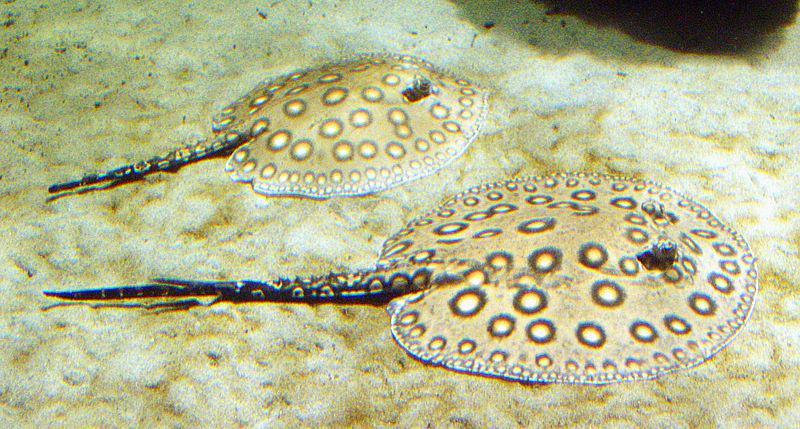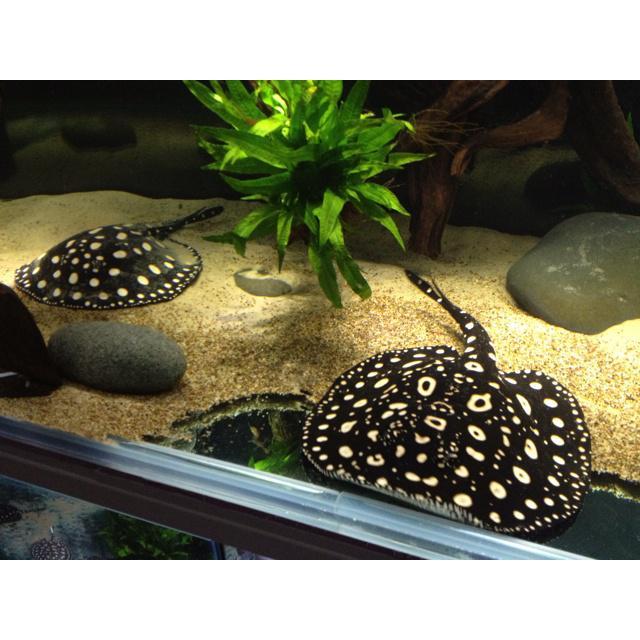The first image is the image on the left, the second image is the image on the right. Considering the images on both sides, is "At least one image contains a sea creature that is not a stingray." valid? Answer yes or no. No. 